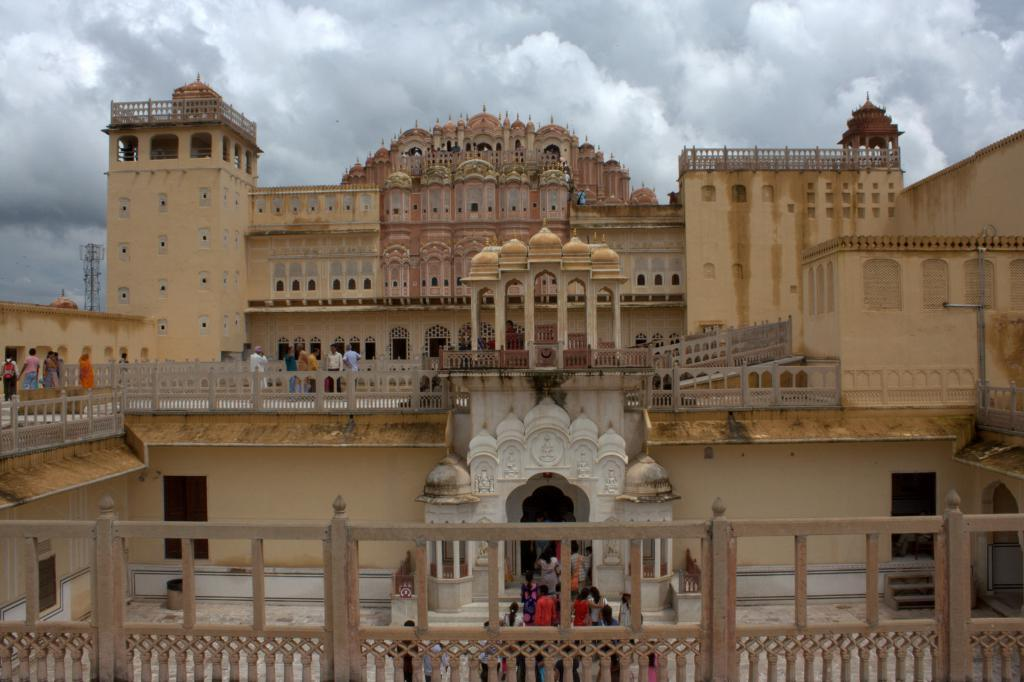What is the main structure in the center of the image? There is a palace in the center of the image. Can you describe the people in the image? There is a group of people in the image. What architectural feature can be seen in the image? There are railings and pillars visible in the image. What can be seen on the palace walls? Windows are visible in the image. What pathway is present in the image? There is a walkway in the image. What is visible at the top of the image? The sky is visible at the top of the image. What type of sponge is being used by the bear in the image? There is no sponge or bear present in the image. 